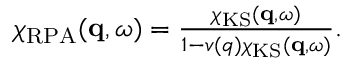<formula> <loc_0><loc_0><loc_500><loc_500>\begin{array} { r } { \chi _ { R P A } ( q , \omega ) = \frac { \chi _ { K S } ( q , \omega ) } { 1 - v ( q ) \chi _ { K S } ( q , \omega ) } . } \end{array}</formula> 